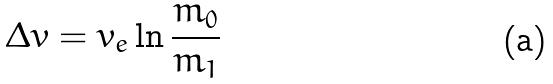Convert formula to latex. <formula><loc_0><loc_0><loc_500><loc_500>\Delta v = v _ { e } \ln \frac { m _ { 0 } } { m _ { 1 } }</formula> 